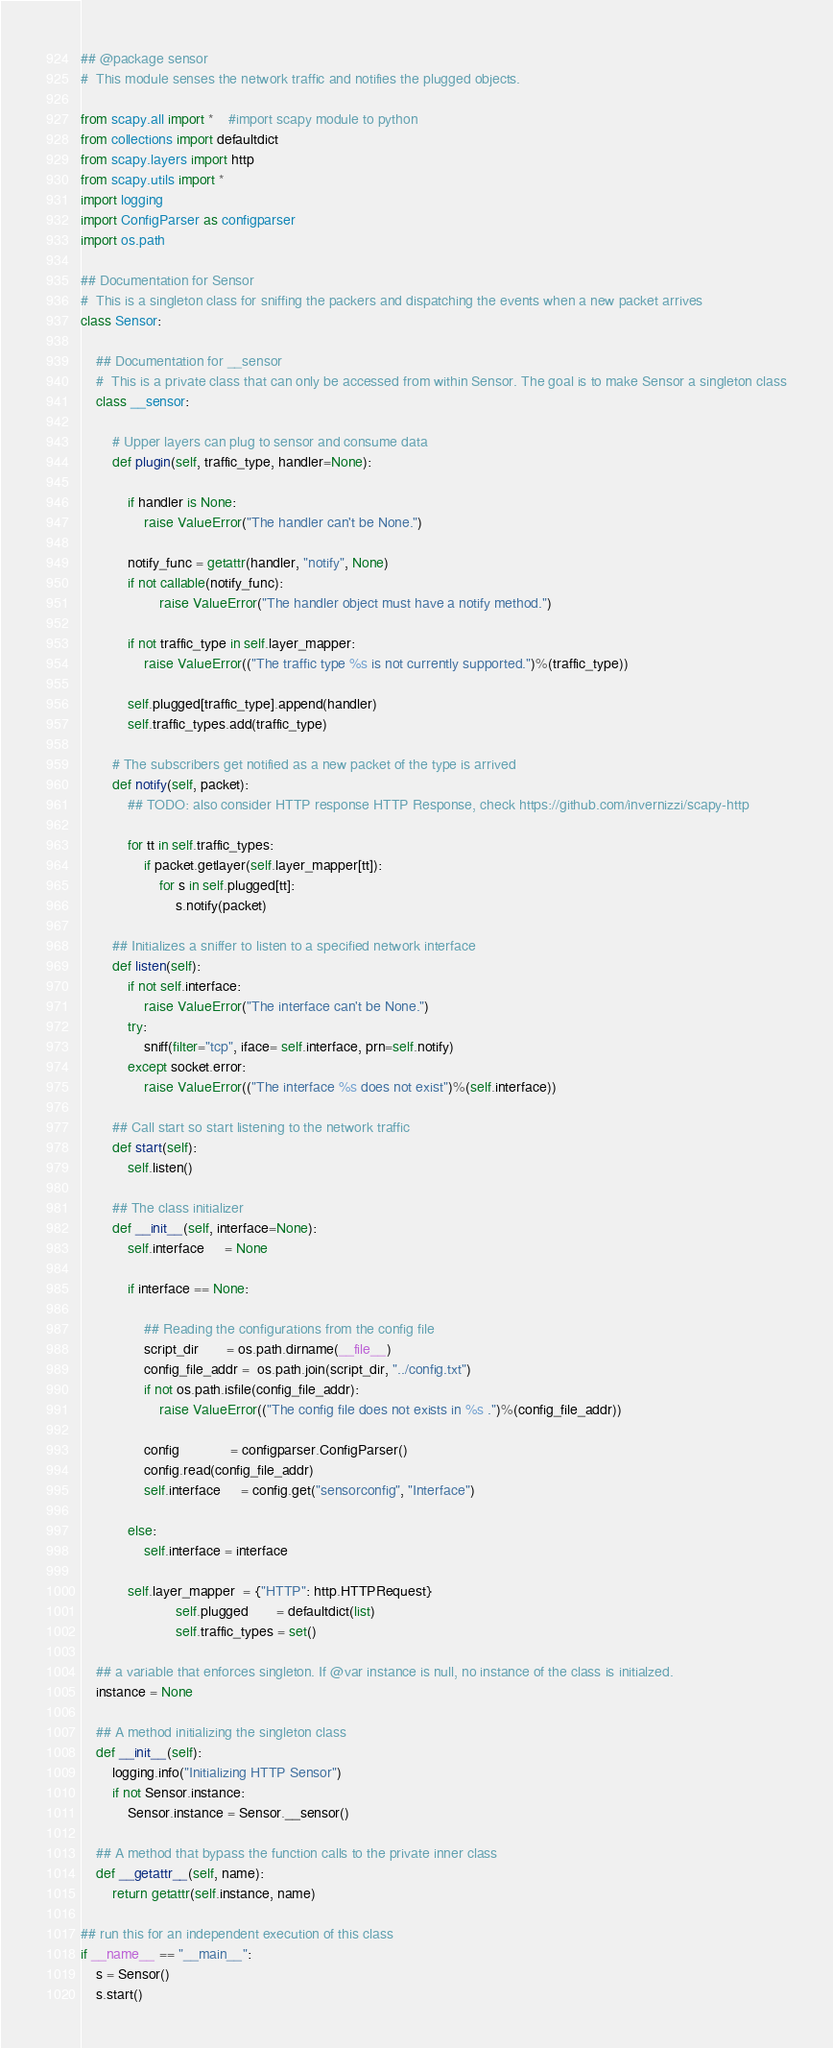Convert code to text. <code><loc_0><loc_0><loc_500><loc_500><_Python_>## @package sensor
#  This module senses the network traffic and notifies the plugged objects.

from scapy.all import *    #import scapy module to python
from collections import defaultdict
from scapy.layers import http
from scapy.utils import *
import logging
import ConfigParser as configparser
import os.path

## Documentation for Sensor
#  This is a singleton class for sniffing the packers and dispatching the events when a new packet arrives
class Sensor:
	
	## Documentation for __sensor
	#  This is a private class that can only be accessed from within Sensor. The goal is to make Sensor a singleton class
	class __sensor:
		
		# Upper layers can plug to sensor and consume data
		def plugin(self, traffic_type, handler=None):

			if handler is None:
				raise ValueError("The handler can't be None.")
			
			notify_func = getattr(handler, "notify", None)
			if not callable(notify_func):
    				raise ValueError("The handler object must have a notify method.")

			if not traffic_type in self.layer_mapper:
				raise ValueError(("The traffic type %s is not currently supported.")%(traffic_type))
			
			self.plugged[traffic_type].append(handler)
			self.traffic_types.add(traffic_type)
		
		# The subscribers get notified as a new packet of the type is arrived
		def notify(self, packet):
			## TODO: also consider HTTP response HTTP Response, check https://github.com/invernizzi/scapy-http

			for tt in self.traffic_types:
				if packet.getlayer(self.layer_mapper[tt]):
					for s in self.plugged[tt]:
						s.notify(packet)
		
		## Initializes a sniffer to listen to a specified network interface
		def listen(self):
			if not self.interface:
				raise ValueError("The interface can't be None.")
			try:
				sniff(filter="tcp", iface= self.interface, prn=self.notify)
			except socket.error:
				raise ValueError(("The interface %s does not exist")%(self.interface))

		## Call start so start listening to the network traffic 
		def start(self):
			self.listen()
		
		## The class initializer
		def __init__(self, interface=None):
			self.interface     = None

			if interface == None:

				## Reading the configurations from the config file
				script_dir       = os.path.dirname(__file__)
				config_file_addr =  os.path.join(script_dir, "../config.txt")
				if not os.path.isfile(config_file_addr):
					raise ValueError(("The config file does not exists in %s .")%(config_file_addr))
				
				config             = configparser.ConfigParser()
				config.read(config_file_addr)
				self.interface     = config.get("sensorconfig", "Interface")
			
			else:
				self.interface = interface
			
			self.layer_mapper  = {"HTTP": http.HTTPRequest}
                        self.plugged       = defaultdict(list)
                        self.traffic_types = set()

	## a variable that enforces singleton. If @var instance is null, no instance of the class is initialzed.
	instance = None
	
	## A method initializing the singleton class
	def __init__(self):
		logging.info("Initializing HTTP Sensor")
		if not Sensor.instance:
			Sensor.instance = Sensor.__sensor()
	
	## A method that bypass the function calls to the private inner class
	def __getattr__(self, name):
		return getattr(self.instance, name)

## run this for an independent execution of this class 
if __name__ == "__main__":
	s = Sensor()
	s.start()
</code> 